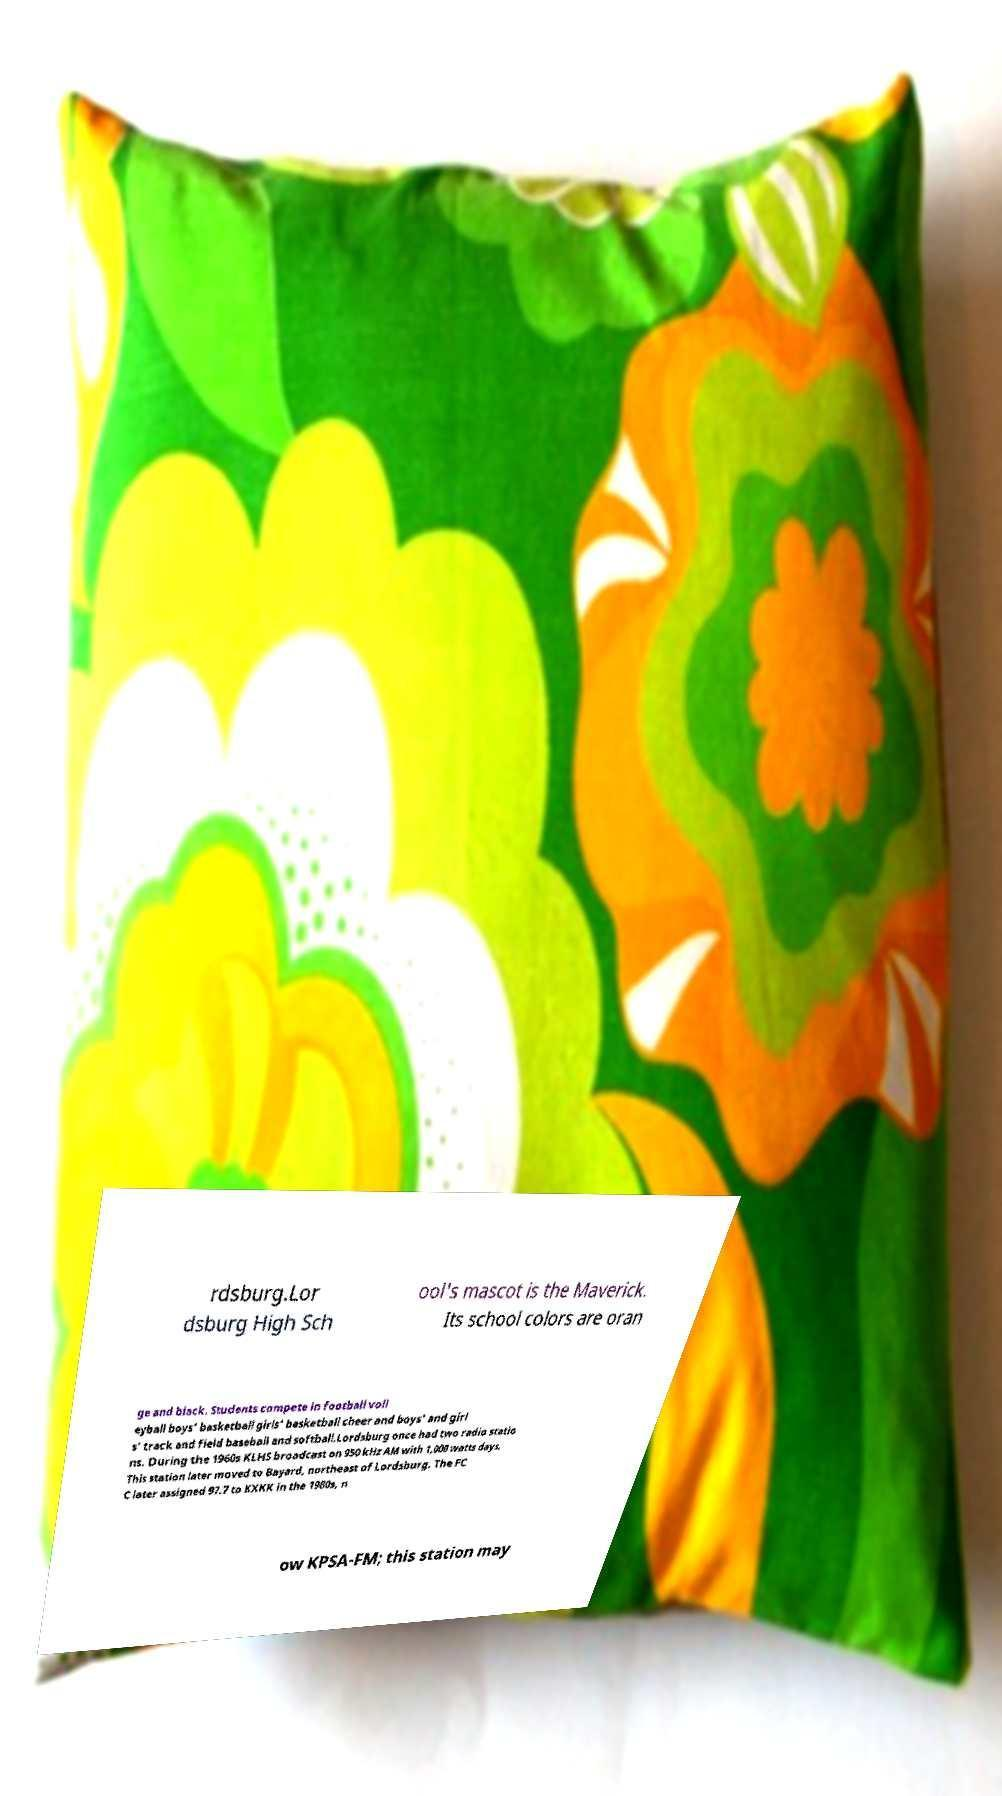What messages or text are displayed in this image? I need them in a readable, typed format. rdsburg.Lor dsburg High Sch ool's mascot is the Maverick. Its school colors are oran ge and black. Students compete in football voll eyball boys' basketball girls' basketball cheer and boys' and girl s' track and field baseball and softball.Lordsburg once had two radio statio ns. During the 1960s KLHS broadcast on 950 kHz AM with 1,000 watts days. This station later moved to Bayard, northeast of Lordsburg. The FC C later assigned 97.7 to KXKK in the 1980s, n ow KPSA-FM; this station may 